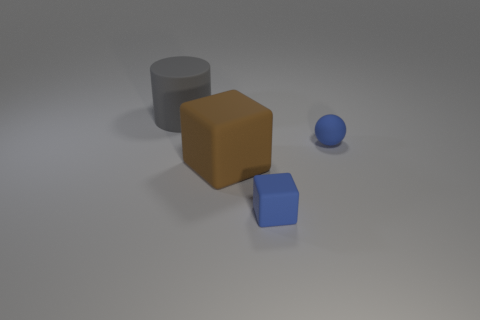How might the arrangement of these objects provide a sense of scale? The objects are placed at various distances, with the small blue rubber cube in the foreground creating a sense of depth relative to the larger structures. The varying sizes and placement of the objects give cues about their relative scales, helping us to infer their sizes in relation to each other. 